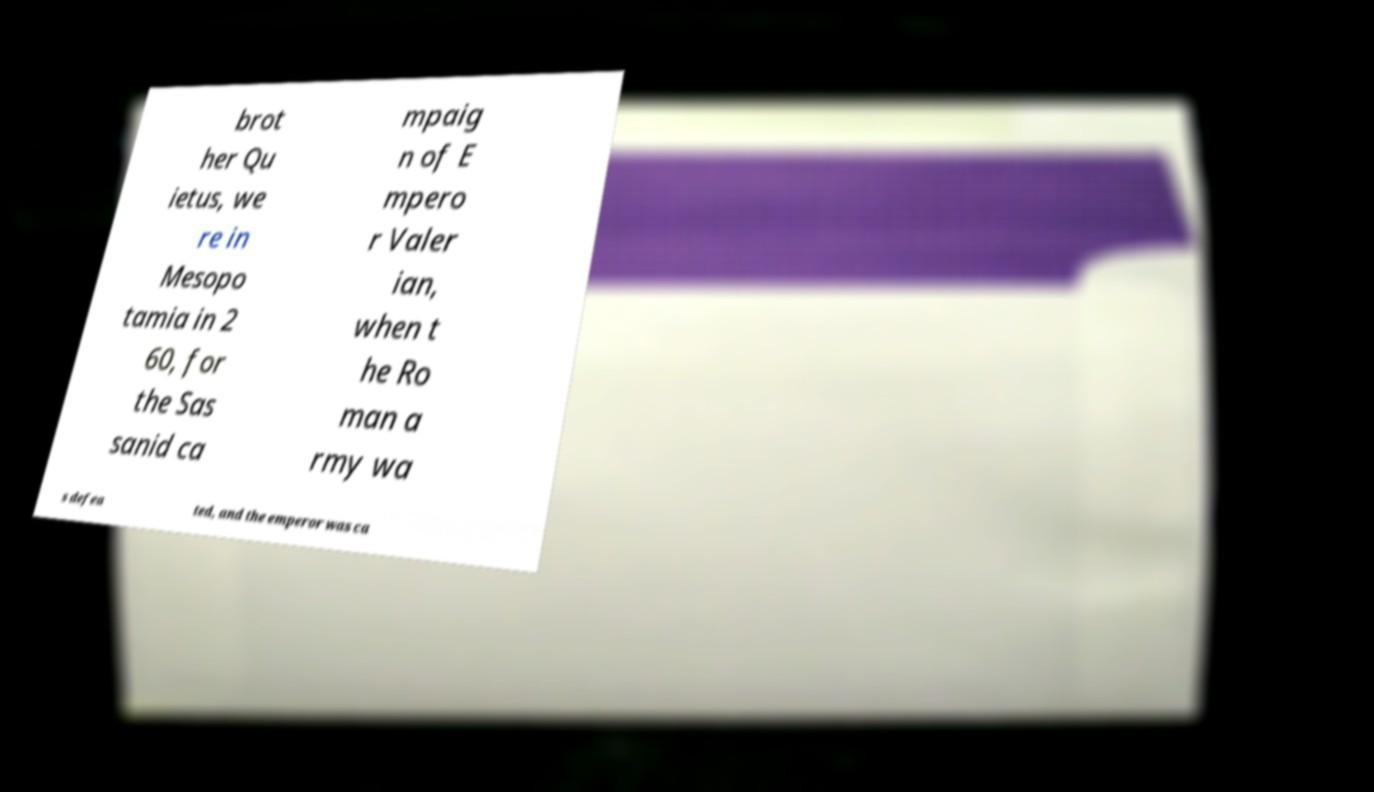Could you extract and type out the text from this image? brot her Qu ietus, we re in Mesopo tamia in 2 60, for the Sas sanid ca mpaig n of E mpero r Valer ian, when t he Ro man a rmy wa s defea ted, and the emperor was ca 